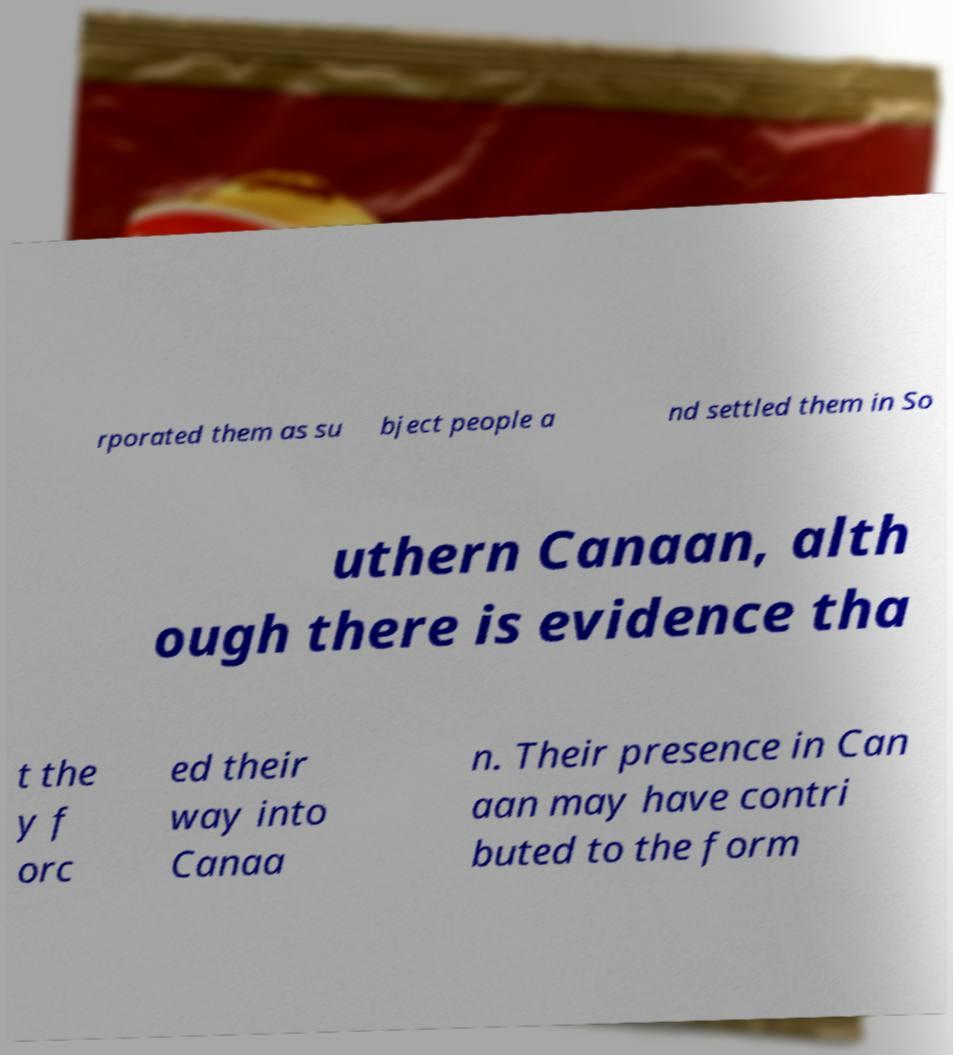Could you extract and type out the text from this image? rporated them as su bject people a nd settled them in So uthern Canaan, alth ough there is evidence tha t the y f orc ed their way into Canaa n. Their presence in Can aan may have contri buted to the form 